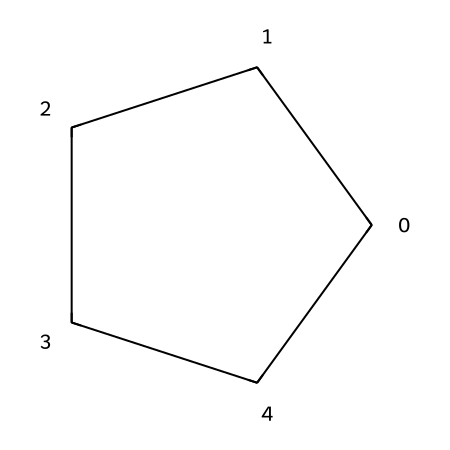What is the molecular formula of cyclopentane? Cyclopentane has five carbon atoms and twelve hydrogen atoms directly derived from its structure, represented by its SMILES. Therefore, the molecular formula is C5H10.
Answer: C5H10 How many carbon atoms are in cyclopentane? The ring structure of cyclopentane as depicted in the SMILES consists of five carbon atoms arranged in a cyclic form.
Answer: 5 What type of chemical bond connects the carbon atoms in cyclopentane? In cyclopentane, each carbon atom is connected to two other carbon atoms through single bonds in a cyclic arrangement, which is characteristic of alkanes.
Answer: single bonds Is cyclopentane a saturated or unsaturated hydrocarbon? Given that cyclopentane contains only single bonds and no double or triple bonds, it is classified as a saturated hydrocarbon.
Answer: saturated What type of structure does cyclopentane have? Cyclopentane has a cyclic structure, where the carbon atoms form a closed loop or ring, typical of cycloalkanes.
Answer: cyclic How many hydrogen atoms are bonded to each carbon atom in cyclopentane? Each carbon atom in cyclopentane is tetrahedral and is bonded to two other carbons and two hydrogen atoms, leading to a total of two hydrogen atoms per carbon.
Answer: 2 What is a common use for cyclopentane in medicine? Cyclopentane is often used as a precursor or a component in the synthesis of mood-stabilizing medications due to its chemical properties and stability.
Answer: mood-stabilizing medications 